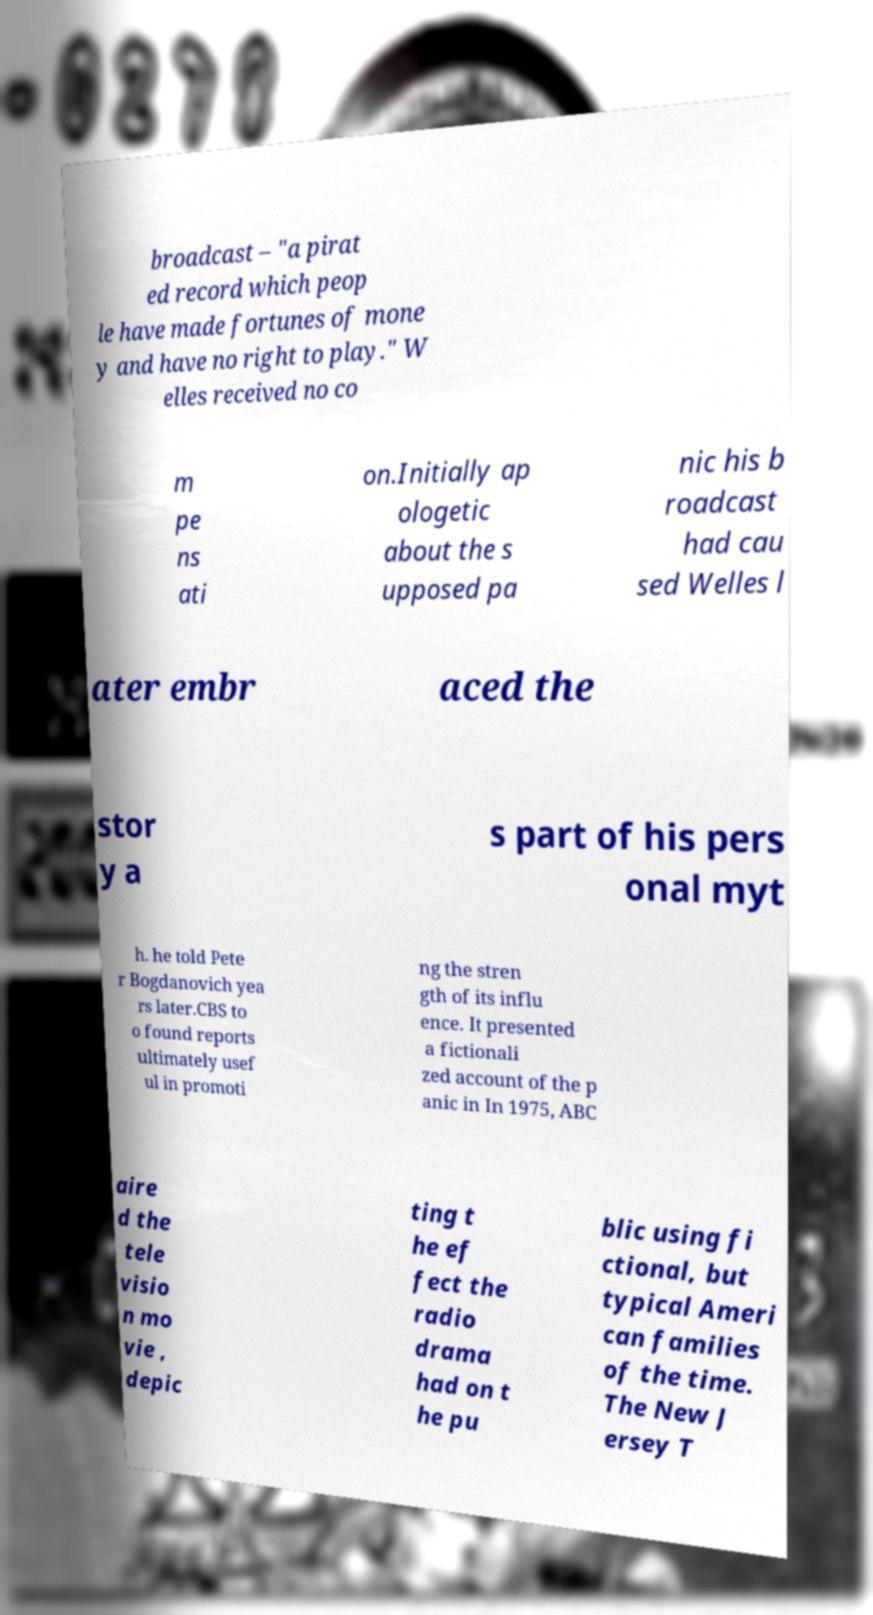For documentation purposes, I need the text within this image transcribed. Could you provide that? broadcast – "a pirat ed record which peop le have made fortunes of mone y and have no right to play." W elles received no co m pe ns ati on.Initially ap ologetic about the s upposed pa nic his b roadcast had cau sed Welles l ater embr aced the stor y a s part of his pers onal myt h. he told Pete r Bogdanovich yea rs later.CBS to o found reports ultimately usef ul in promoti ng the stren gth of its influ ence. It presented a fictionali zed account of the p anic in In 1975, ABC aire d the tele visio n mo vie , depic ting t he ef fect the radio drama had on t he pu blic using fi ctional, but typical Ameri can families of the time. The New J ersey T 